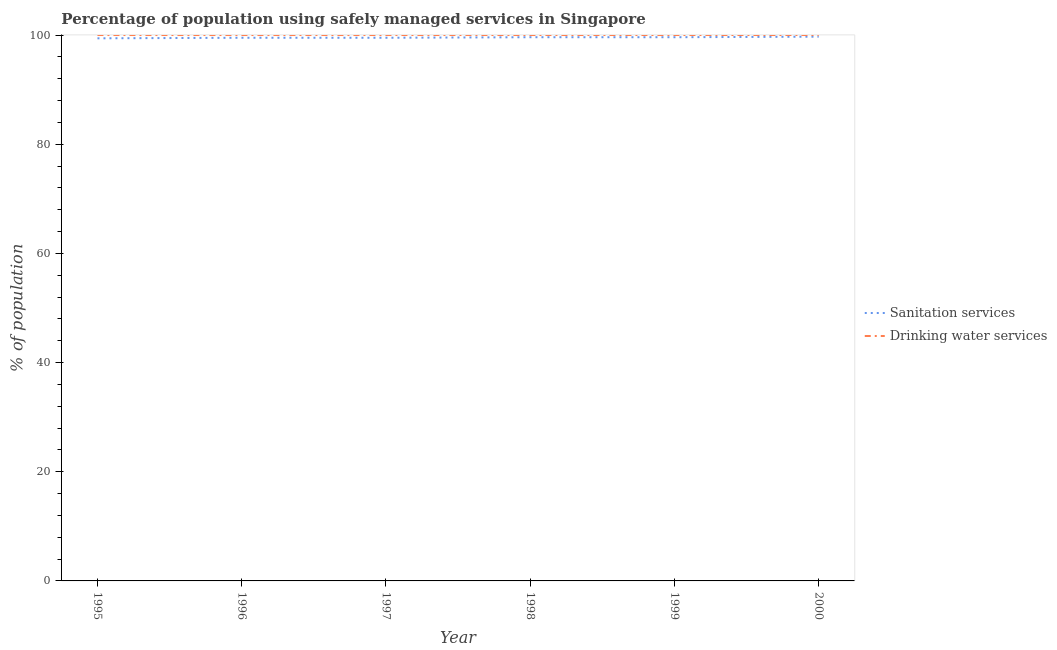Is the number of lines equal to the number of legend labels?
Offer a very short reply. Yes. What is the percentage of population who used drinking water services in 1999?
Offer a very short reply. 100. Across all years, what is the maximum percentage of population who used drinking water services?
Offer a terse response. 100. Across all years, what is the minimum percentage of population who used sanitation services?
Your answer should be compact. 99.4. In which year was the percentage of population who used sanitation services maximum?
Provide a succinct answer. 2000. In which year was the percentage of population who used sanitation services minimum?
Your answer should be very brief. 1995. What is the total percentage of population who used sanitation services in the graph?
Provide a short and direct response. 597.3. What is the difference between the percentage of population who used drinking water services in 1997 and that in 2000?
Offer a terse response. 0. What is the difference between the percentage of population who used drinking water services in 1997 and the percentage of population who used sanitation services in 1996?
Provide a succinct answer. 0.5. In the year 1996, what is the difference between the percentage of population who used drinking water services and percentage of population who used sanitation services?
Offer a very short reply. 0.5. What is the ratio of the percentage of population who used sanitation services in 1999 to that in 2000?
Your answer should be very brief. 1. Is the difference between the percentage of population who used drinking water services in 1995 and 1999 greater than the difference between the percentage of population who used sanitation services in 1995 and 1999?
Your answer should be compact. Yes. What is the difference between the highest and the second highest percentage of population who used sanitation services?
Your answer should be very brief. 0.1. What is the difference between the highest and the lowest percentage of population who used drinking water services?
Give a very brief answer. 0. How many years are there in the graph?
Make the answer very short. 6. What is the difference between two consecutive major ticks on the Y-axis?
Provide a succinct answer. 20. Are the values on the major ticks of Y-axis written in scientific E-notation?
Keep it short and to the point. No. How many legend labels are there?
Give a very brief answer. 2. What is the title of the graph?
Keep it short and to the point. Percentage of population using safely managed services in Singapore. What is the label or title of the X-axis?
Give a very brief answer. Year. What is the label or title of the Y-axis?
Give a very brief answer. % of population. What is the % of population in Sanitation services in 1995?
Provide a short and direct response. 99.4. What is the % of population in Drinking water services in 1995?
Your answer should be very brief. 100. What is the % of population in Sanitation services in 1996?
Your answer should be very brief. 99.5. What is the % of population of Sanitation services in 1997?
Your response must be concise. 99.5. What is the % of population of Drinking water services in 1997?
Keep it short and to the point. 100. What is the % of population in Sanitation services in 1998?
Your answer should be compact. 99.6. What is the % of population of Sanitation services in 1999?
Make the answer very short. 99.6. What is the % of population in Drinking water services in 1999?
Provide a succinct answer. 100. What is the % of population of Sanitation services in 2000?
Offer a very short reply. 99.7. Across all years, what is the maximum % of population in Sanitation services?
Provide a succinct answer. 99.7. Across all years, what is the minimum % of population in Sanitation services?
Provide a succinct answer. 99.4. Across all years, what is the minimum % of population in Drinking water services?
Provide a succinct answer. 100. What is the total % of population of Sanitation services in the graph?
Your answer should be very brief. 597.3. What is the total % of population in Drinking water services in the graph?
Ensure brevity in your answer.  600. What is the difference between the % of population in Sanitation services in 1995 and that in 1996?
Your answer should be very brief. -0.1. What is the difference between the % of population of Drinking water services in 1995 and that in 1997?
Make the answer very short. 0. What is the difference between the % of population in Drinking water services in 1995 and that in 1999?
Your response must be concise. 0. What is the difference between the % of population in Drinking water services in 1995 and that in 2000?
Offer a terse response. 0. What is the difference between the % of population of Sanitation services in 1996 and that in 1999?
Ensure brevity in your answer.  -0.1. What is the difference between the % of population in Drinking water services in 1996 and that in 1999?
Give a very brief answer. 0. What is the difference between the % of population in Sanitation services in 1996 and that in 2000?
Make the answer very short. -0.2. What is the difference between the % of population of Sanitation services in 1997 and that in 1998?
Provide a succinct answer. -0.1. What is the difference between the % of population in Drinking water services in 1997 and that in 1998?
Provide a succinct answer. 0. What is the difference between the % of population in Sanitation services in 1997 and that in 1999?
Offer a very short reply. -0.1. What is the difference between the % of population of Drinking water services in 1997 and that in 1999?
Ensure brevity in your answer.  0. What is the difference between the % of population of Sanitation services in 1997 and that in 2000?
Offer a very short reply. -0.2. What is the difference between the % of population of Drinking water services in 1997 and that in 2000?
Offer a terse response. 0. What is the difference between the % of population of Drinking water services in 1998 and that in 1999?
Offer a very short reply. 0. What is the difference between the % of population in Sanitation services in 1998 and that in 2000?
Offer a very short reply. -0.1. What is the difference between the % of population of Sanitation services in 1999 and that in 2000?
Ensure brevity in your answer.  -0.1. What is the difference between the % of population in Sanitation services in 1995 and the % of population in Drinking water services in 1997?
Provide a succinct answer. -0.6. What is the difference between the % of population of Sanitation services in 1995 and the % of population of Drinking water services in 1998?
Your answer should be compact. -0.6. What is the difference between the % of population in Sanitation services in 1995 and the % of population in Drinking water services in 1999?
Keep it short and to the point. -0.6. What is the difference between the % of population of Sanitation services in 1995 and the % of population of Drinking water services in 2000?
Provide a succinct answer. -0.6. What is the difference between the % of population of Sanitation services in 1996 and the % of population of Drinking water services in 1997?
Provide a succinct answer. -0.5. What is the difference between the % of population in Sanitation services in 1996 and the % of population in Drinking water services in 1998?
Your response must be concise. -0.5. What is the difference between the % of population in Sanitation services in 1996 and the % of population in Drinking water services in 1999?
Keep it short and to the point. -0.5. What is the difference between the % of population of Sanitation services in 1996 and the % of population of Drinking water services in 2000?
Your answer should be very brief. -0.5. What is the difference between the % of population of Sanitation services in 1997 and the % of population of Drinking water services in 1998?
Your answer should be very brief. -0.5. What is the difference between the % of population of Sanitation services in 1997 and the % of population of Drinking water services in 2000?
Your response must be concise. -0.5. What is the difference between the % of population in Sanitation services in 1999 and the % of population in Drinking water services in 2000?
Ensure brevity in your answer.  -0.4. What is the average % of population in Sanitation services per year?
Keep it short and to the point. 99.55. In the year 1996, what is the difference between the % of population in Sanitation services and % of population in Drinking water services?
Give a very brief answer. -0.5. In the year 1999, what is the difference between the % of population in Sanitation services and % of population in Drinking water services?
Keep it short and to the point. -0.4. What is the ratio of the % of population in Drinking water services in 1995 to that in 1996?
Provide a short and direct response. 1. What is the ratio of the % of population of Sanitation services in 1995 to that in 1997?
Your answer should be compact. 1. What is the ratio of the % of population of Sanitation services in 1995 to that in 1998?
Keep it short and to the point. 1. What is the ratio of the % of population in Sanitation services in 1995 to that in 1999?
Provide a short and direct response. 1. What is the ratio of the % of population of Sanitation services in 1995 to that in 2000?
Offer a very short reply. 1. What is the ratio of the % of population of Sanitation services in 1996 to that in 1997?
Provide a succinct answer. 1. What is the ratio of the % of population of Drinking water services in 1996 to that in 1997?
Your answer should be compact. 1. What is the ratio of the % of population in Sanitation services in 1996 to that in 1998?
Offer a terse response. 1. What is the ratio of the % of population in Drinking water services in 1996 to that in 1998?
Keep it short and to the point. 1. What is the ratio of the % of population in Sanitation services in 1996 to that in 1999?
Ensure brevity in your answer.  1. What is the ratio of the % of population in Sanitation services in 1996 to that in 2000?
Ensure brevity in your answer.  1. What is the ratio of the % of population in Drinking water services in 1996 to that in 2000?
Your answer should be very brief. 1. What is the ratio of the % of population in Sanitation services in 1997 to that in 1998?
Offer a very short reply. 1. What is the ratio of the % of population of Drinking water services in 1997 to that in 1998?
Make the answer very short. 1. What is the ratio of the % of population in Sanitation services in 1997 to that in 1999?
Your response must be concise. 1. What is the ratio of the % of population of Drinking water services in 1997 to that in 1999?
Make the answer very short. 1. What is the ratio of the % of population in Sanitation services in 1997 to that in 2000?
Keep it short and to the point. 1. What is the ratio of the % of population of Drinking water services in 1997 to that in 2000?
Offer a very short reply. 1. What is the ratio of the % of population of Drinking water services in 1998 to that in 2000?
Your answer should be very brief. 1. What is the ratio of the % of population in Sanitation services in 1999 to that in 2000?
Give a very brief answer. 1. What is the difference between the highest and the lowest % of population of Drinking water services?
Your answer should be very brief. 0. 